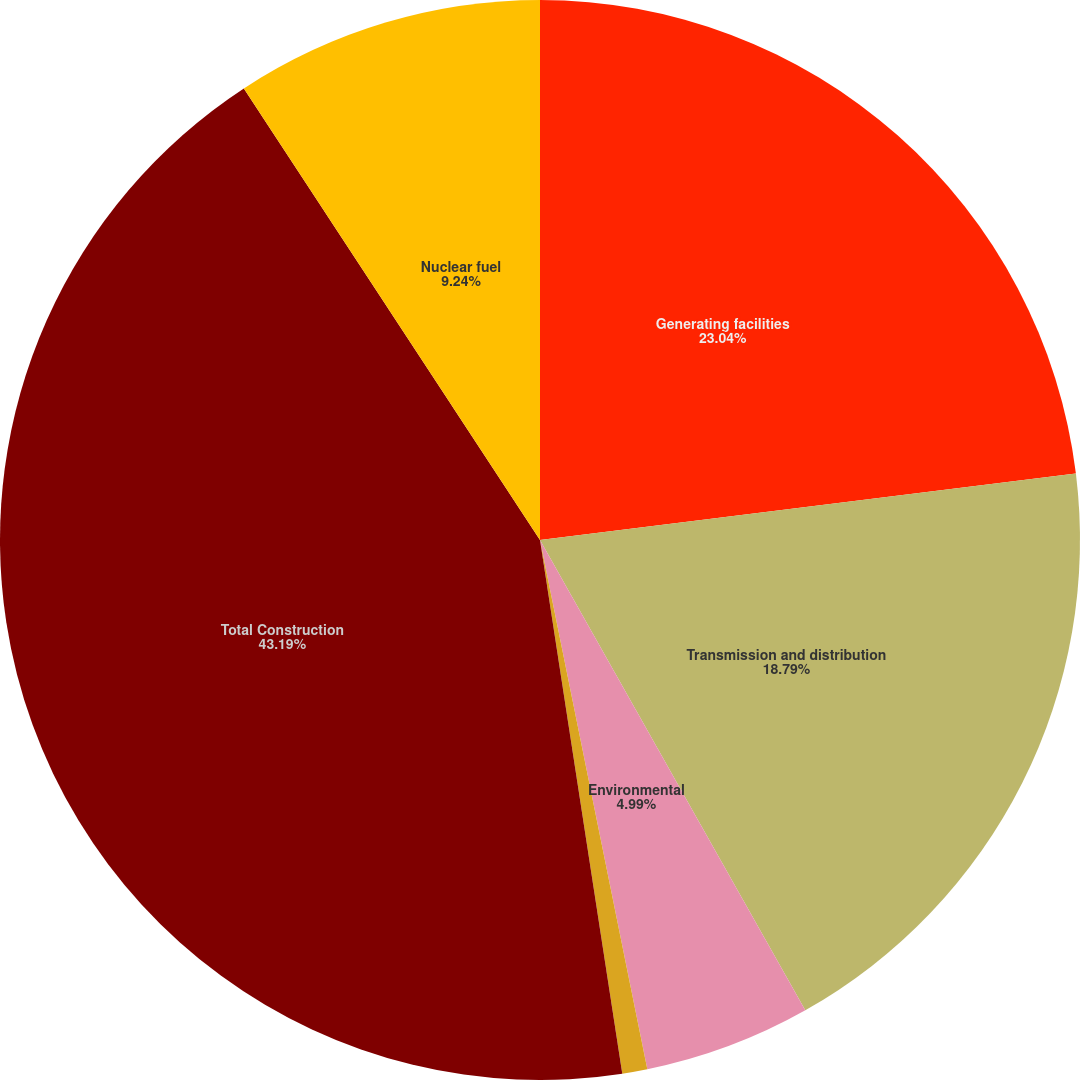Convert chart. <chart><loc_0><loc_0><loc_500><loc_500><pie_chart><fcel>Generating facilities<fcel>Transmission and distribution<fcel>Environmental<fcel>Other<fcel>Total Construction<fcel>Nuclear fuel<nl><fcel>23.04%<fcel>18.79%<fcel>4.99%<fcel>0.75%<fcel>43.2%<fcel>9.24%<nl></chart> 